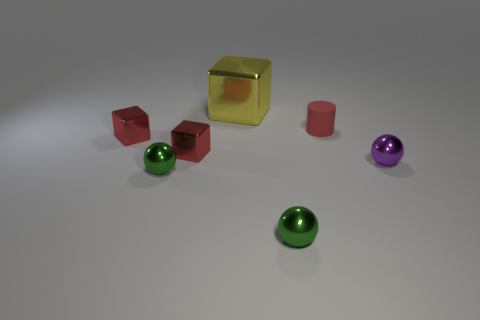Are there any metallic objects of the same color as the small matte object?
Your response must be concise. Yes. Are the large thing and the red cylinder made of the same material?
Provide a short and direct response. No. What number of small blue matte balls are there?
Give a very brief answer. 0. What color is the small metal cube that is on the right side of the metal sphere left of the shiny block that is behind the rubber thing?
Your answer should be compact. Red. What number of things are behind the purple sphere and on the right side of the big yellow metal thing?
Make the answer very short. 1. What number of shiny things are either green things or small gray cylinders?
Make the answer very short. 2. There is a tiny sphere on the left side of the cube that is behind the small cylinder; what is its material?
Keep it short and to the point. Metal. What shape is the purple object that is the same size as the matte cylinder?
Your answer should be compact. Sphere. Is the number of small red metal cubes less than the number of small yellow objects?
Provide a short and direct response. No. Are there any metal objects left of the small metallic ball that is on the right side of the small red matte cylinder?
Keep it short and to the point. Yes. 